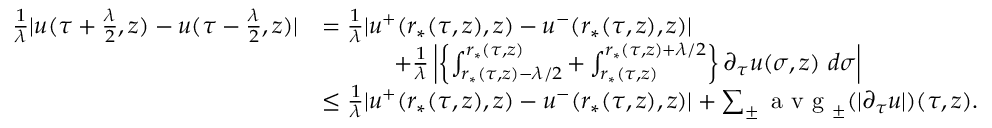<formula> <loc_0><loc_0><loc_500><loc_500>\begin{array} { r l } { \frac { 1 } { \lambda } | u ( \tau + \frac { \lambda } { 2 } , z ) - u ( \tau - \frac { \lambda } { 2 } , z ) | } & { = \frac { 1 } { \lambda } | u ^ { + } ( r _ { * } ( \tau , z ) , z ) - u ^ { - } ( r _ { * } ( \tau , z ) , z ) | } \\ & { \quad + \frac { 1 } { \lambda } \left | \left \{ \int _ { r _ { * } ( \tau , z ) - \lambda / 2 } ^ { r _ { * } ( \tau , z ) } + \int _ { r _ { * } ( \tau , z ) } ^ { r _ { * } ( \tau , z ) + \lambda / 2 } \right \} \partial _ { \tau } u ( \sigma , z ) \ d \sigma \right | } \\ & { \leq \frac { 1 } { \lambda } | u ^ { + } ( r _ { * } ( \tau , z ) , z ) - u ^ { - } ( r _ { * } ( \tau , z ) , z ) | + \sum _ { \pm } a v g _ { \pm } ( | \partial _ { \tau } u | ) ( \tau , z ) . } \end{array}</formula> 